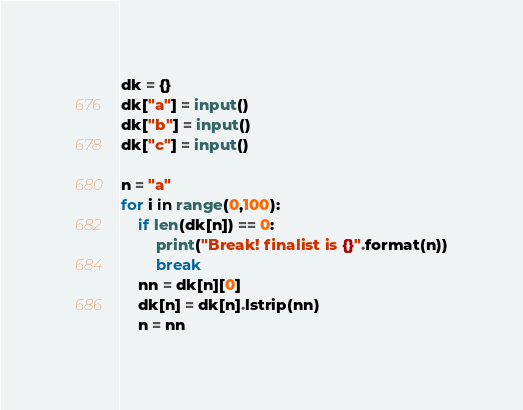Convert code to text. <code><loc_0><loc_0><loc_500><loc_500><_Python_>dk = {}
dk["a"] = input()
dk["b"] = input()
dk["c"] = input()

n = "a"
for i in range(0,100):
    if len(dk[n]) == 0:
        print("Break! finalist is {}".format(n))
        break
    nn = dk[n][0]
    dk[n] = dk[n].lstrip(nn)
    n = nn
</code> 